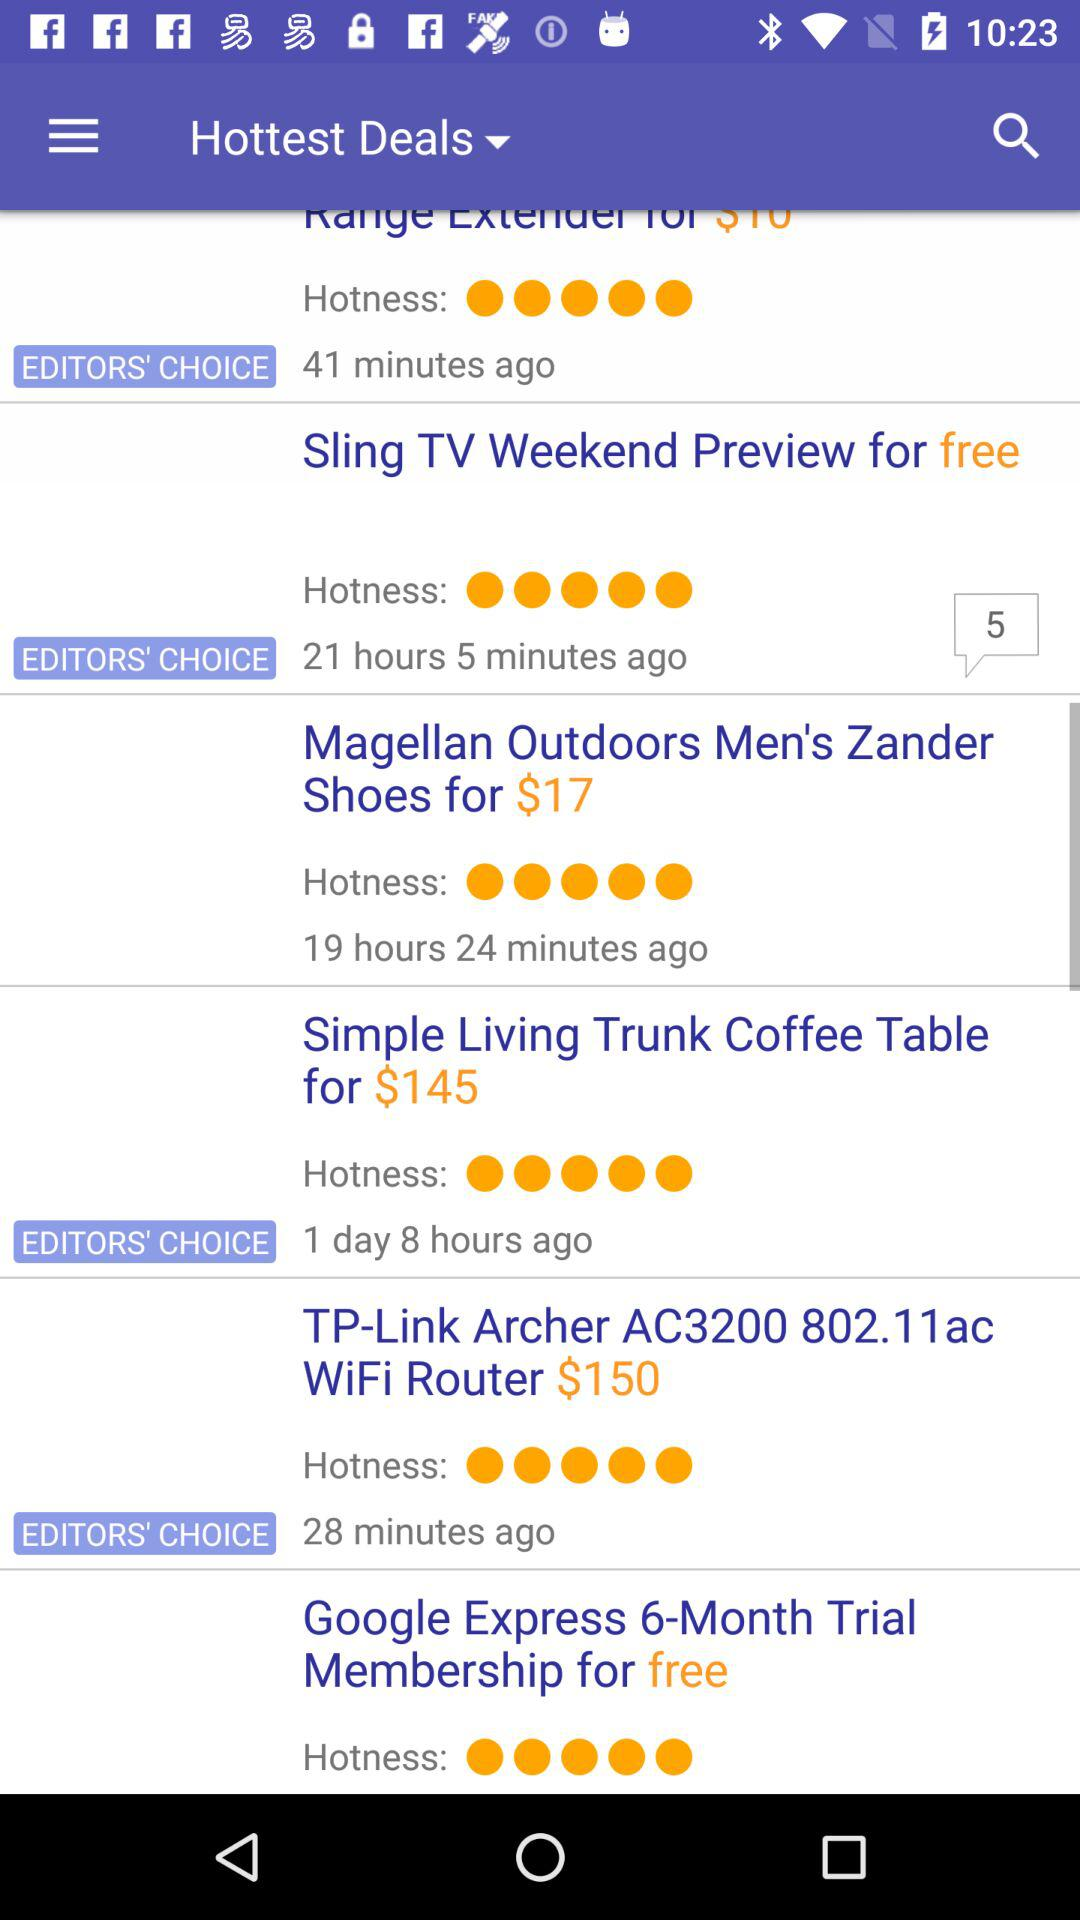How many hours ago was the "Simple Living Trunk Coffee Table" deal started? The "Simple Living Trunk Coffee Table" deal was started 1 day 8 hours ago. 